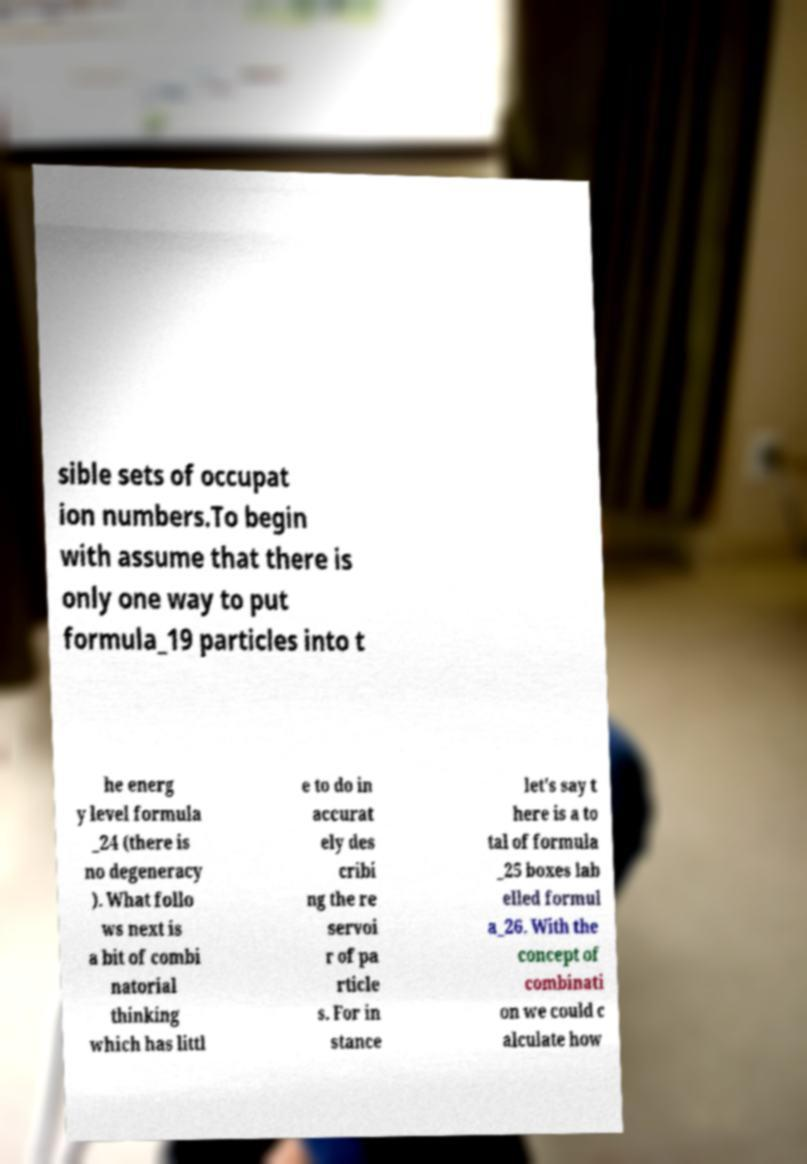Could you extract and type out the text from this image? sible sets of occupat ion numbers.To begin with assume that there is only one way to put formula_19 particles into t he energ y level formula _24 (there is no degeneracy ). What follo ws next is a bit of combi natorial thinking which has littl e to do in accurat ely des cribi ng the re servoi r of pa rticle s. For in stance let's say t here is a to tal of formula _25 boxes lab elled formul a_26. With the concept of combinati on we could c alculate how 